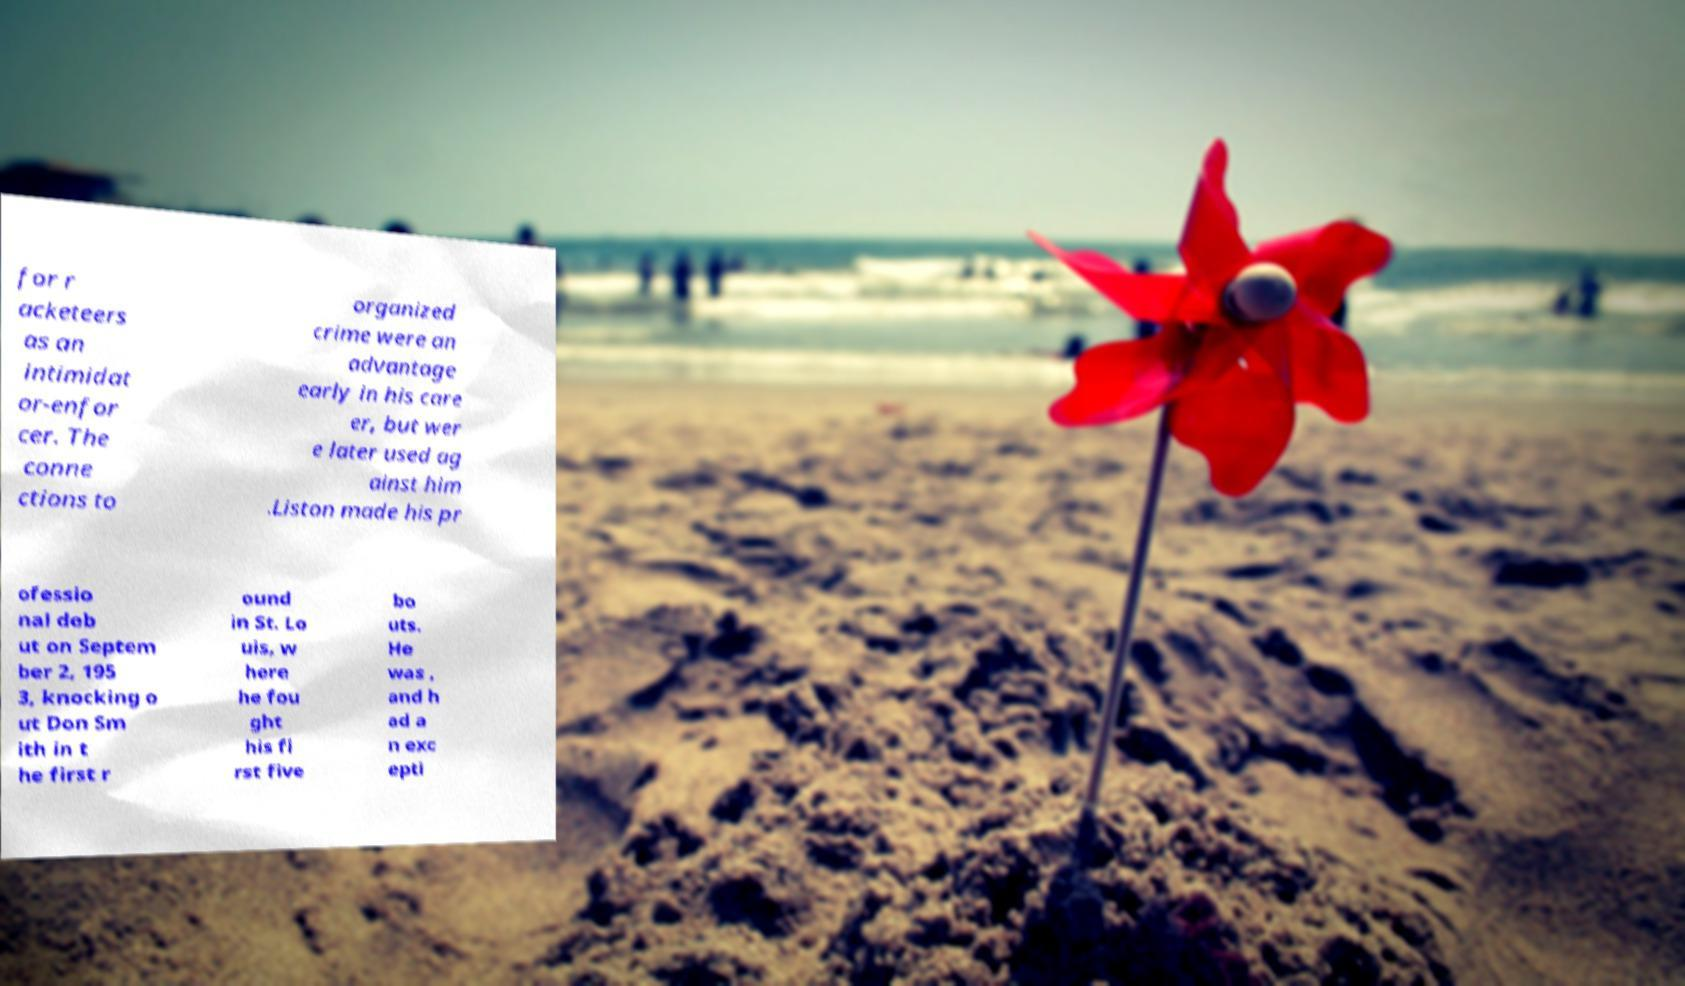Can you accurately transcribe the text from the provided image for me? for r acketeers as an intimidat or-enfor cer. The conne ctions to organized crime were an advantage early in his care er, but wer e later used ag ainst him .Liston made his pr ofessio nal deb ut on Septem ber 2, 195 3, knocking o ut Don Sm ith in t he first r ound in St. Lo uis, w here he fou ght his fi rst five bo uts. He was , and h ad a n exc epti 